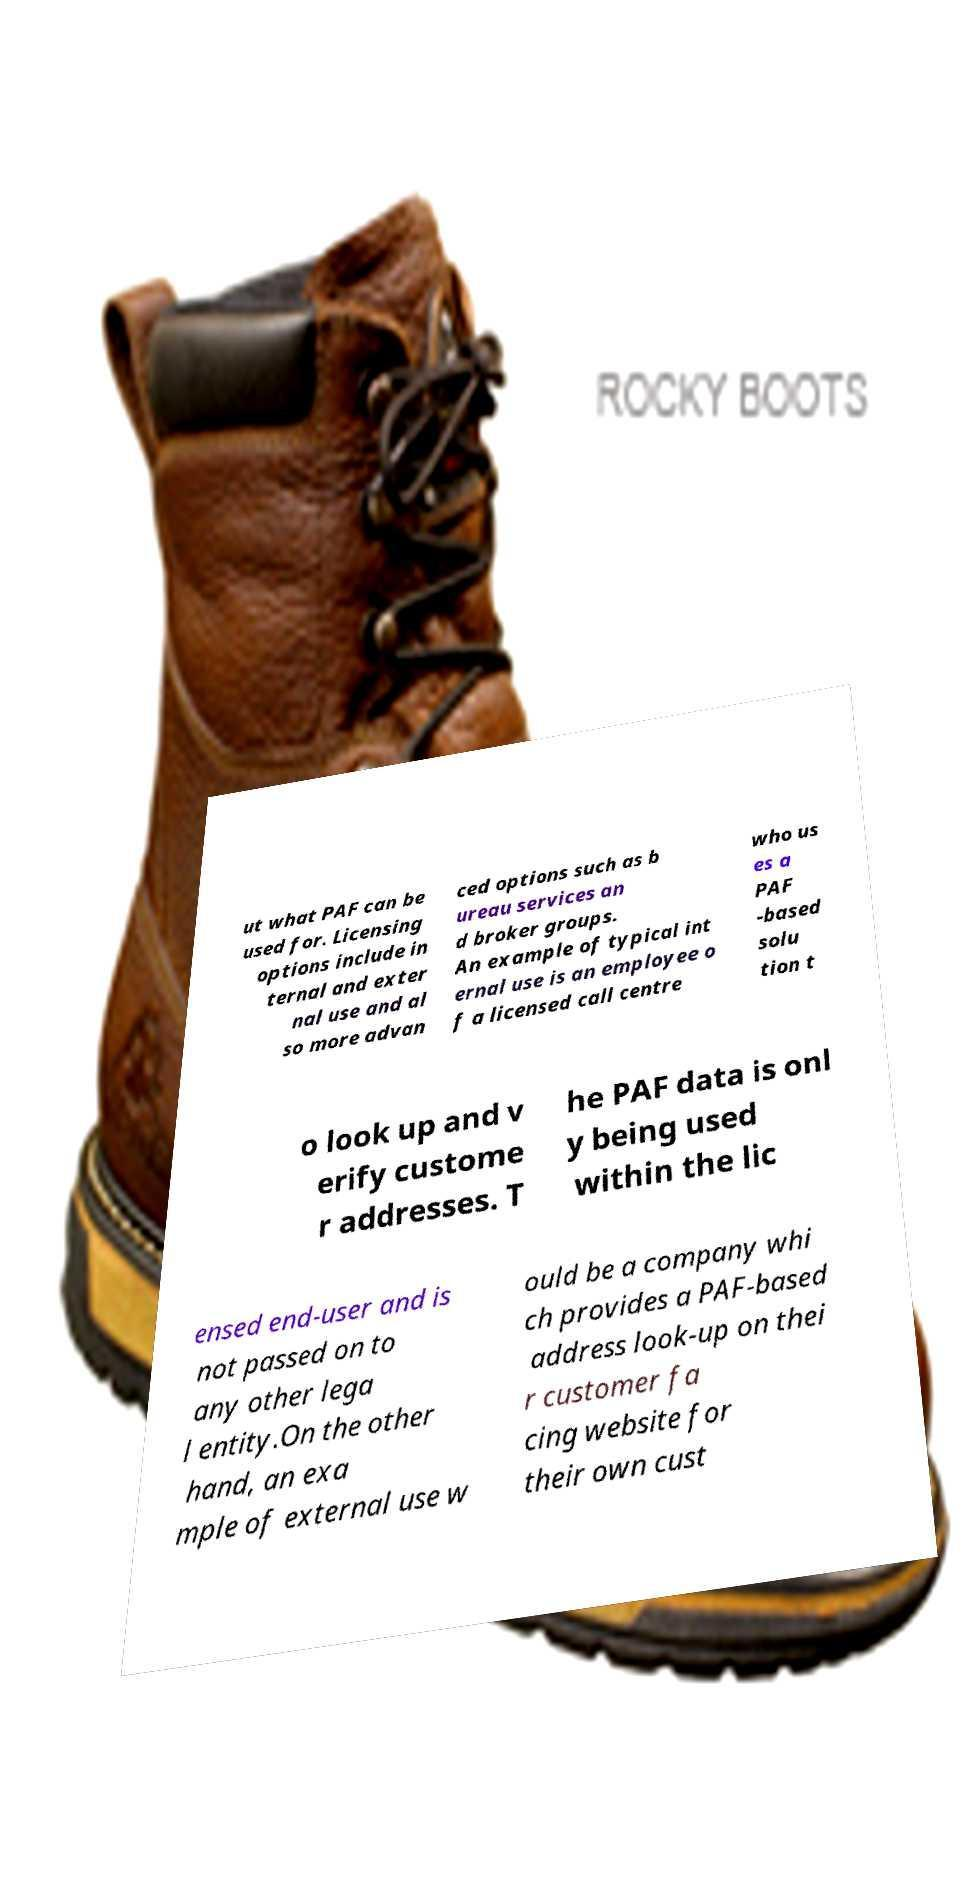There's text embedded in this image that I need extracted. Can you transcribe it verbatim? ut what PAF can be used for. Licensing options include in ternal and exter nal use and al so more advan ced options such as b ureau services an d broker groups. An example of typical int ernal use is an employee o f a licensed call centre who us es a PAF -based solu tion t o look up and v erify custome r addresses. T he PAF data is onl y being used within the lic ensed end-user and is not passed on to any other lega l entity.On the other hand, an exa mple of external use w ould be a company whi ch provides a PAF-based address look-up on thei r customer fa cing website for their own cust 